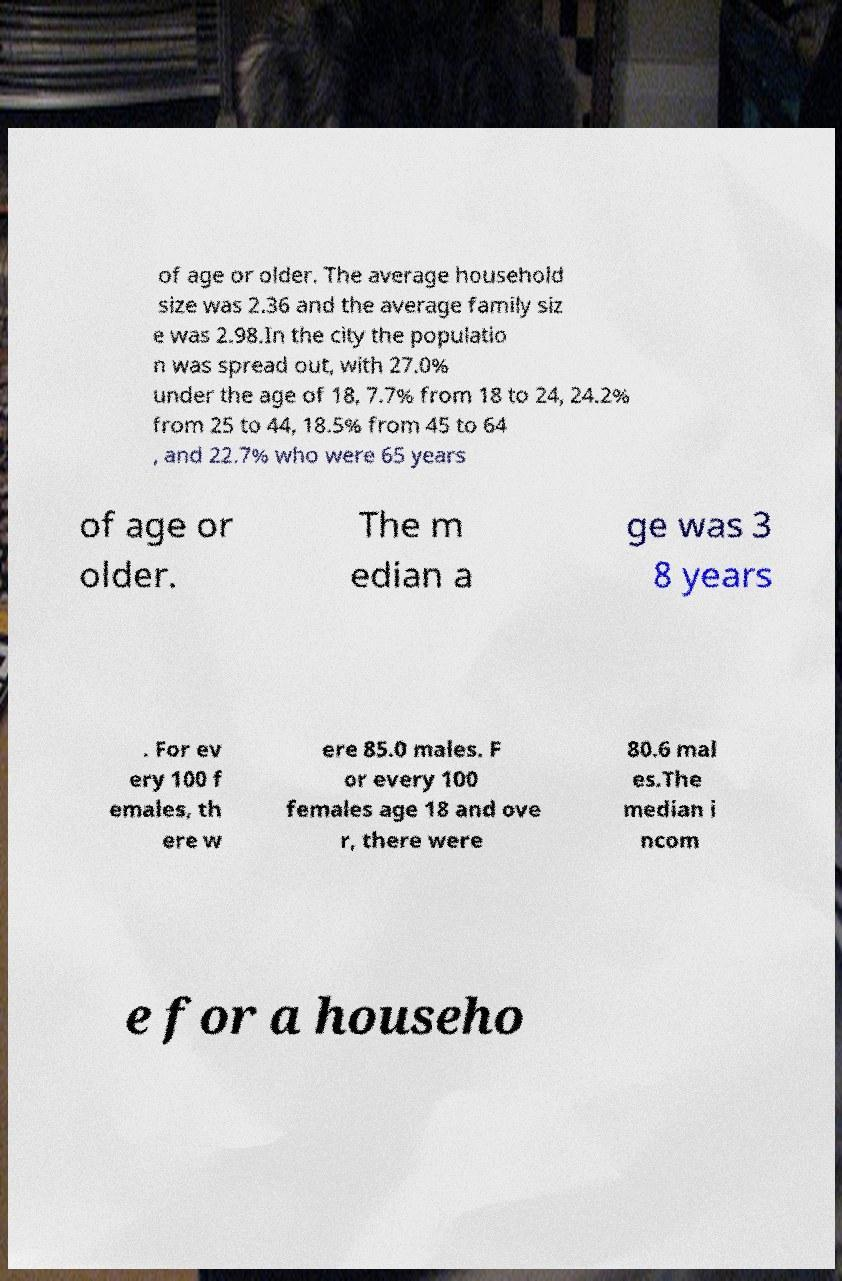There's text embedded in this image that I need extracted. Can you transcribe it verbatim? of age or older. The average household size was 2.36 and the average family siz e was 2.98.In the city the populatio n was spread out, with 27.0% under the age of 18, 7.7% from 18 to 24, 24.2% from 25 to 44, 18.5% from 45 to 64 , and 22.7% who were 65 years of age or older. The m edian a ge was 3 8 years . For ev ery 100 f emales, th ere w ere 85.0 males. F or every 100 females age 18 and ove r, there were 80.6 mal es.The median i ncom e for a househo 